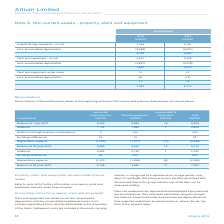According to Altium Limited's financial document, What is the total consolidated amount in 2019? According to the financial document, 7,762 (in thousands). The relevant text states: "7,762 5,712..." Also, When are subsequent costs included? when it is probable that future economic benefits associated with the item will flow to the group and the cost of the item can be measured reliably. The document states: "when it is probable that future economic benefits associated with the item will flow to the group and the cost of the item can be measured reliably...." Also, What are the years included in the table? The document shows two values: 2019 and 2018. From the document: "30 June 2019 51 2018..." Additionally, Which year had a higher total consolidated Non-current assets value? According to the financial document, 2019. The relevant text states: "30 June 2019 51..." Also, can you calculate: What is the percentage change in the plant and equipment at cost less accumulated depreciation from 2018 to 2019? To answer this question, I need to perform calculations using the financial data. The calculation is: (3,645-3,020)/3,020, which equals 20.7 (percentage). This is based on the information: "3,645 3,020 3,645 3,020..." The key data points involved are: 3,020, 3,645. Also, can you calculate: What is the percentage change in the leasehold improvements before depreciation from 2018 from 2019? To answer this question, I need to perform calculations using the financial data. The calculation is: (7,754-5,181)/5,181, which equals 49.66 (percentage). This is based on the information: "Leasehold improvements - at cost 7,754 5,181 Leasehold improvements - at cost 7,754 5,181..." The key data points involved are: 5,181, 7,754. 